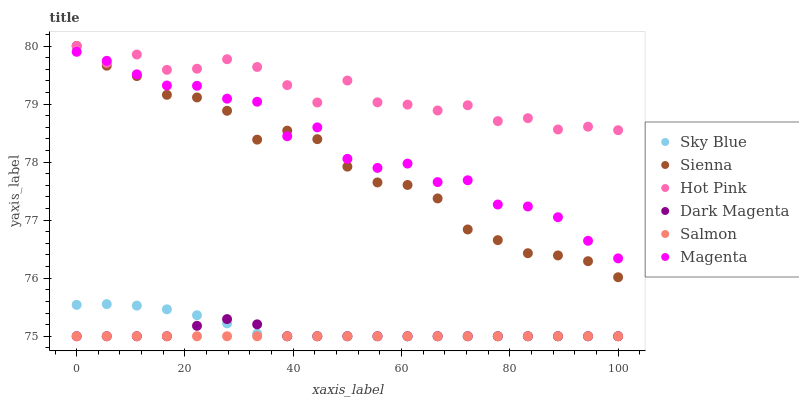Does Salmon have the minimum area under the curve?
Answer yes or no. Yes. Does Hot Pink have the maximum area under the curve?
Answer yes or no. Yes. Does Hot Pink have the minimum area under the curve?
Answer yes or no. No. Does Salmon have the maximum area under the curve?
Answer yes or no. No. Is Salmon the smoothest?
Answer yes or no. Yes. Is Magenta the roughest?
Answer yes or no. Yes. Is Hot Pink the smoothest?
Answer yes or no. No. Is Hot Pink the roughest?
Answer yes or no. No. Does Dark Magenta have the lowest value?
Answer yes or no. Yes. Does Hot Pink have the lowest value?
Answer yes or no. No. Does Sienna have the highest value?
Answer yes or no. Yes. Does Salmon have the highest value?
Answer yes or no. No. Is Salmon less than Hot Pink?
Answer yes or no. Yes. Is Hot Pink greater than Dark Magenta?
Answer yes or no. Yes. Does Magenta intersect Hot Pink?
Answer yes or no. Yes. Is Magenta less than Hot Pink?
Answer yes or no. No. Is Magenta greater than Hot Pink?
Answer yes or no. No. Does Salmon intersect Hot Pink?
Answer yes or no. No. 